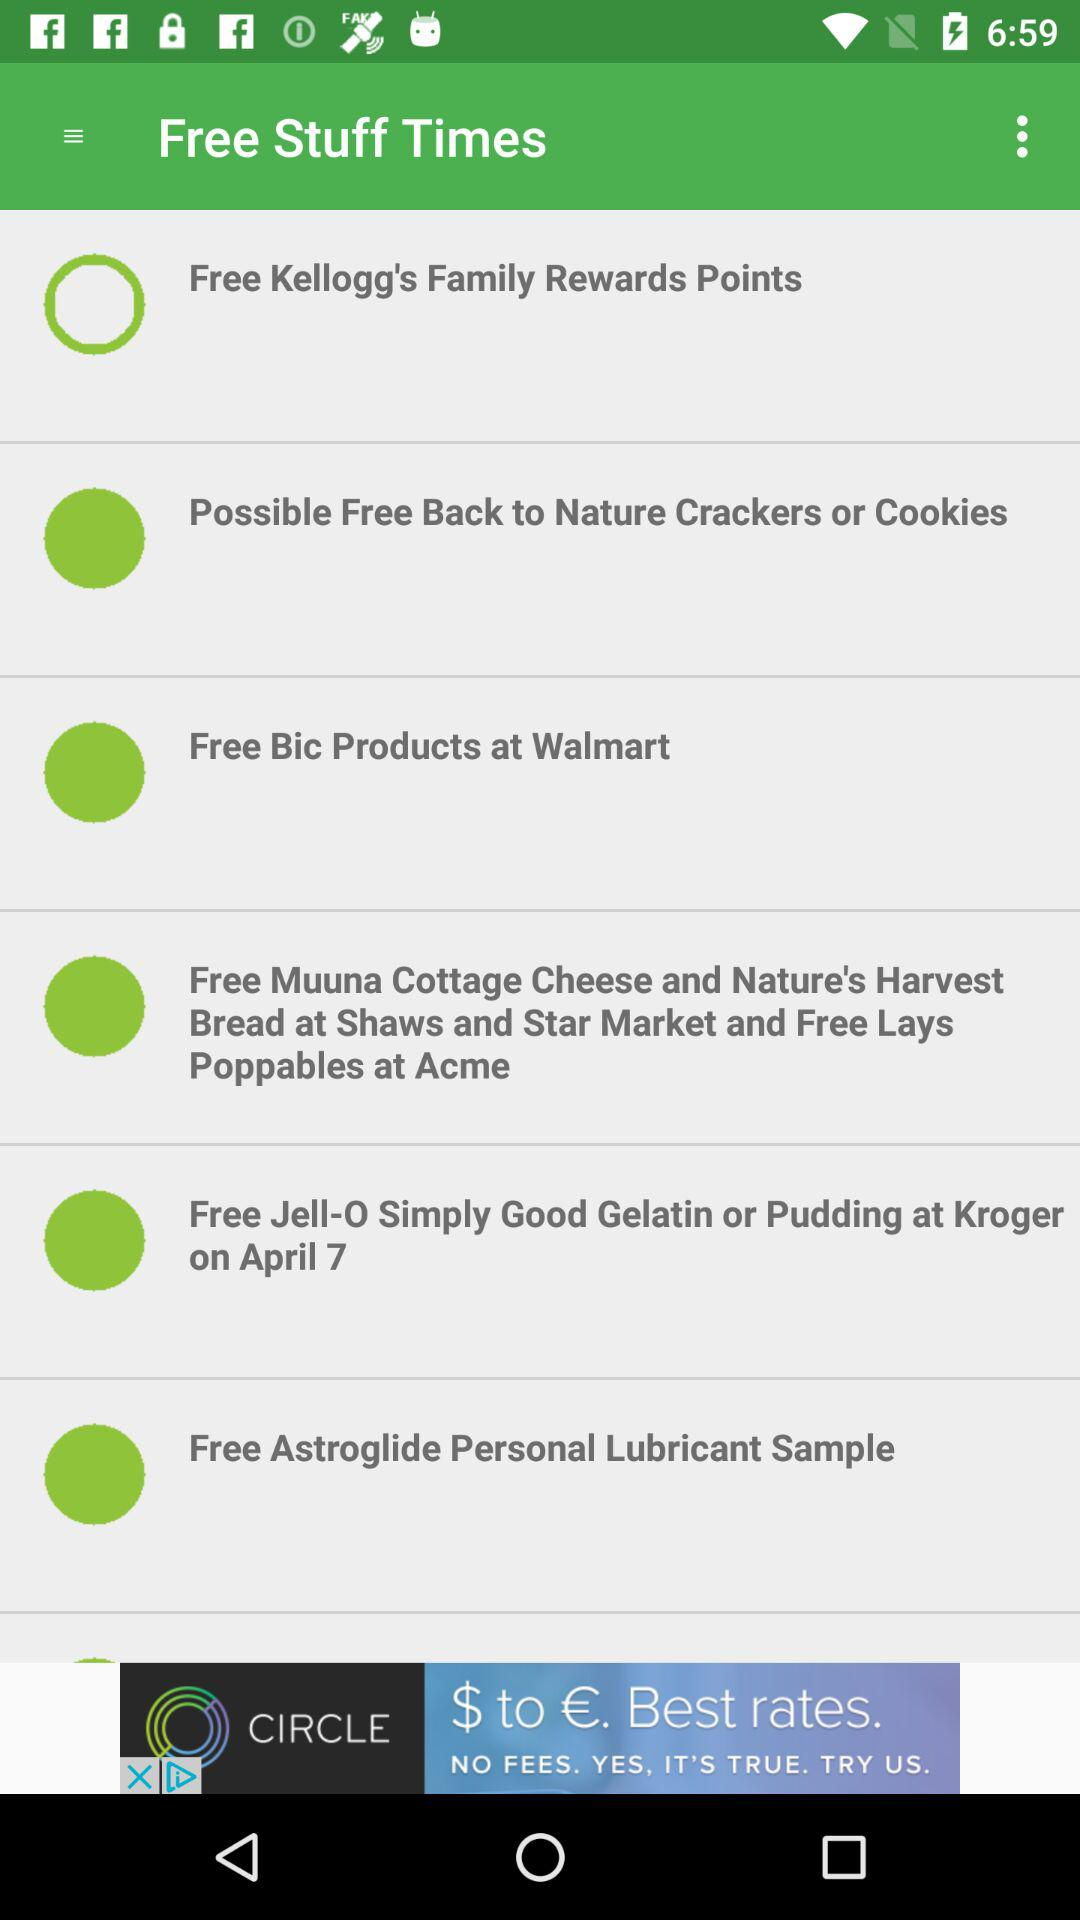What is the app name? The app name is "Free Stuff Times". 